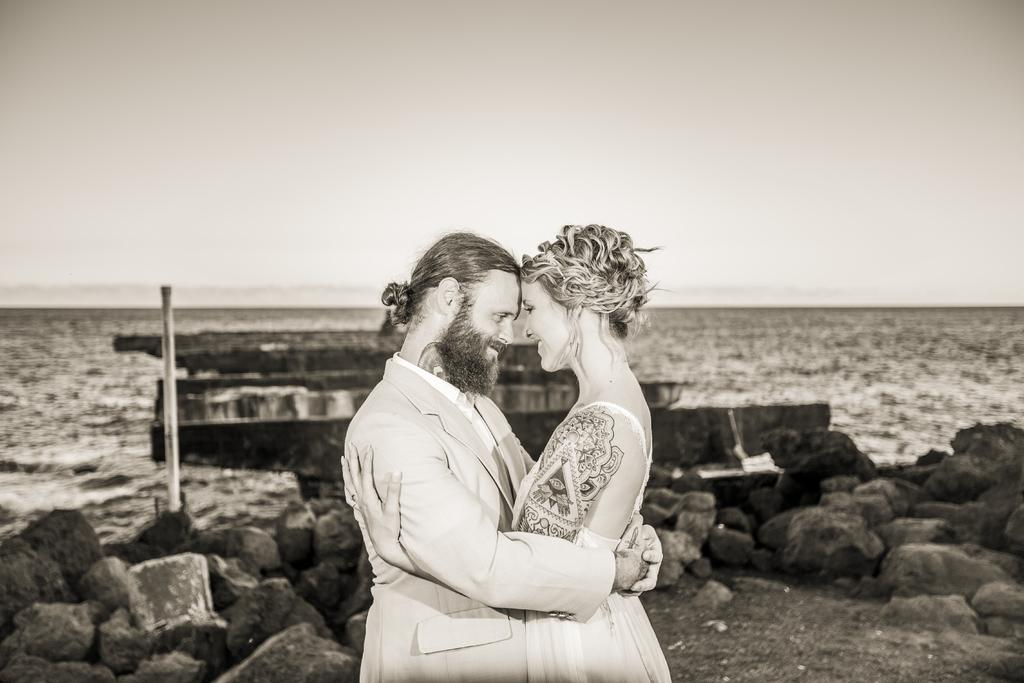How many people are in the image? There are two persons standing in the middle of the image. What are the people doing in the image? The persons are smiling. What can be seen behind the persons in the image? There are stones and water visible behind the persons. What is visible at the top of the image? The sky is visible at the top of the image. What type of beast can be seen in the image? There is no beast present in the image. What date is marked on the calendar in the image? There is no calendar present in the image. 